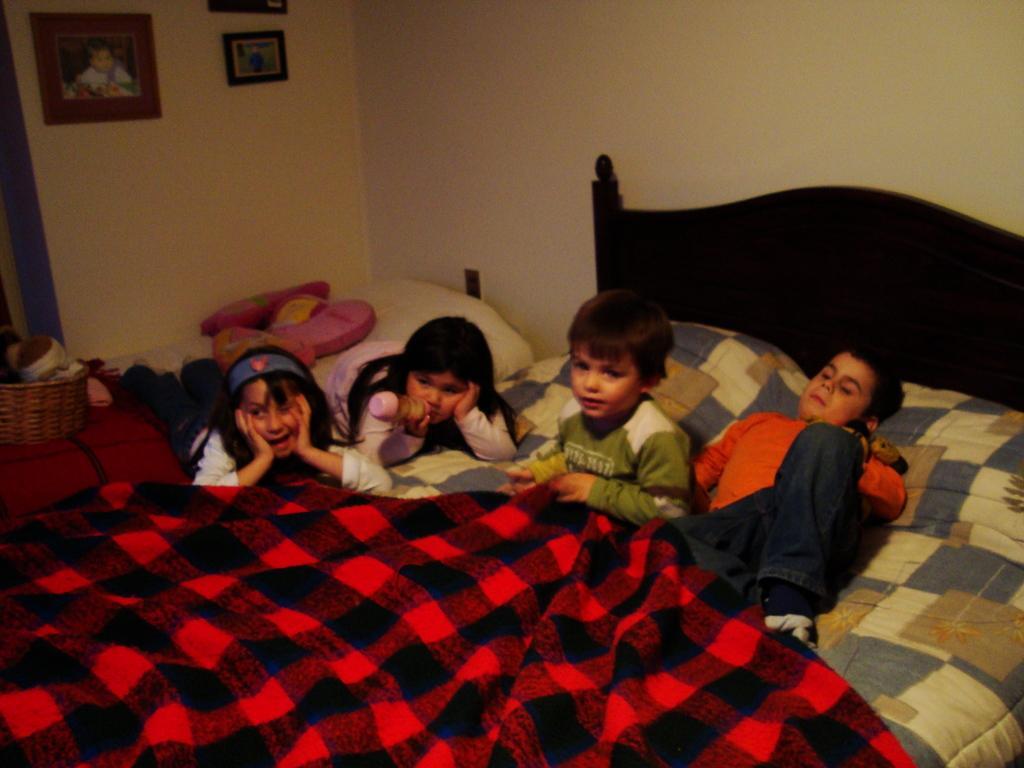Could you give a brief overview of what you see in this image? This picture is clicked in a room. Here, we see four children lying on bed. We even see red bed sheet on the bed. Behind them, we see a white wall on which three photo frames are placed. 